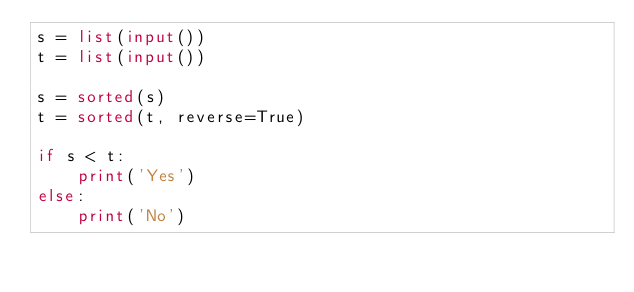Convert code to text. <code><loc_0><loc_0><loc_500><loc_500><_Python_>s = list(input())
t = list(input())

s = sorted(s)
t = sorted(t, reverse=True)

if s < t:
    print('Yes')
else:
    print('No')
</code> 